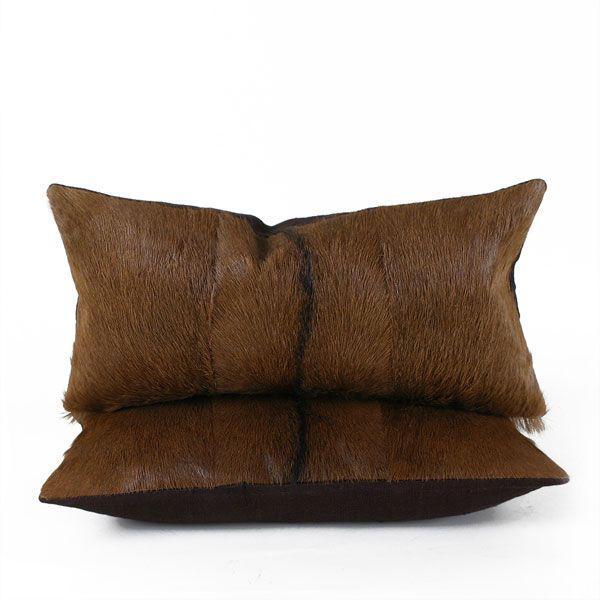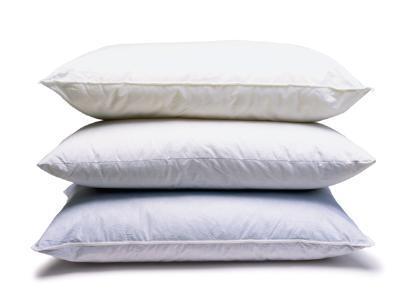The first image is the image on the left, the second image is the image on the right. Analyze the images presented: Is the assertion "The lefthand image contains a vertical stack of three solid-white pillows." valid? Answer yes or no. No. The first image is the image on the left, the second image is the image on the right. Examine the images to the left and right. Is the description "The right image contains three pillows stacked on top of each other." accurate? Answer yes or no. Yes. 